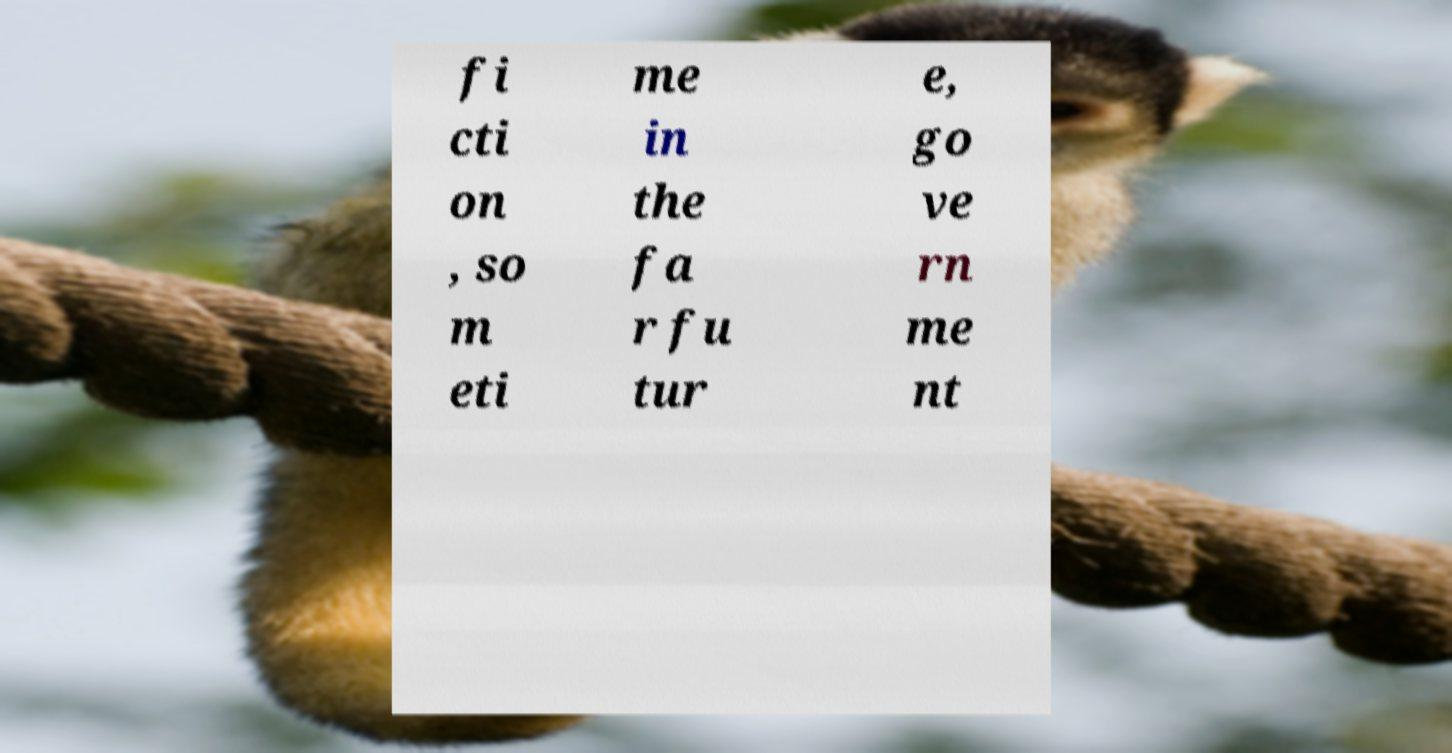Can you accurately transcribe the text from the provided image for me? fi cti on , so m eti me in the fa r fu tur e, go ve rn me nt 